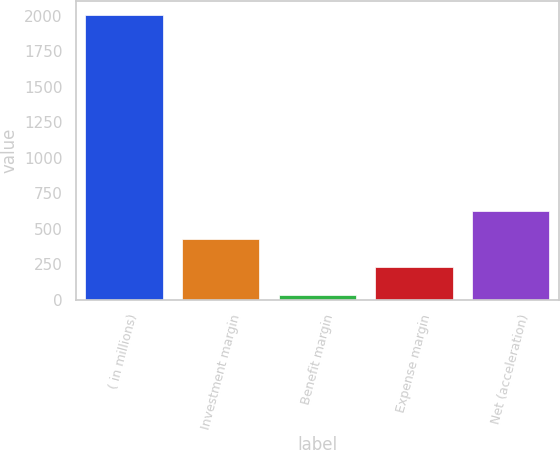<chart> <loc_0><loc_0><loc_500><loc_500><bar_chart><fcel>( in millions)<fcel>Investment margin<fcel>Benefit margin<fcel>Expense margin<fcel>Net (acceleration)<nl><fcel>2008<fcel>429.6<fcel>35<fcel>232.3<fcel>626.9<nl></chart> 